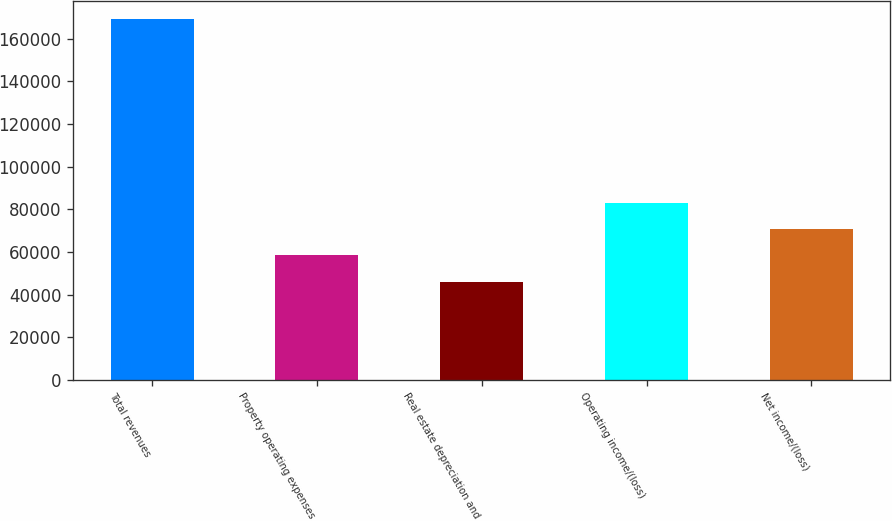Convert chart. <chart><loc_0><loc_0><loc_500><loc_500><bar_chart><fcel>Total revenues<fcel>Property operating expenses<fcel>Real estate depreciation and<fcel>Operating income/(loss)<fcel>Net income/(loss)<nl><fcel>169175<fcel>58439<fcel>46135<fcel>83047<fcel>70743<nl></chart> 